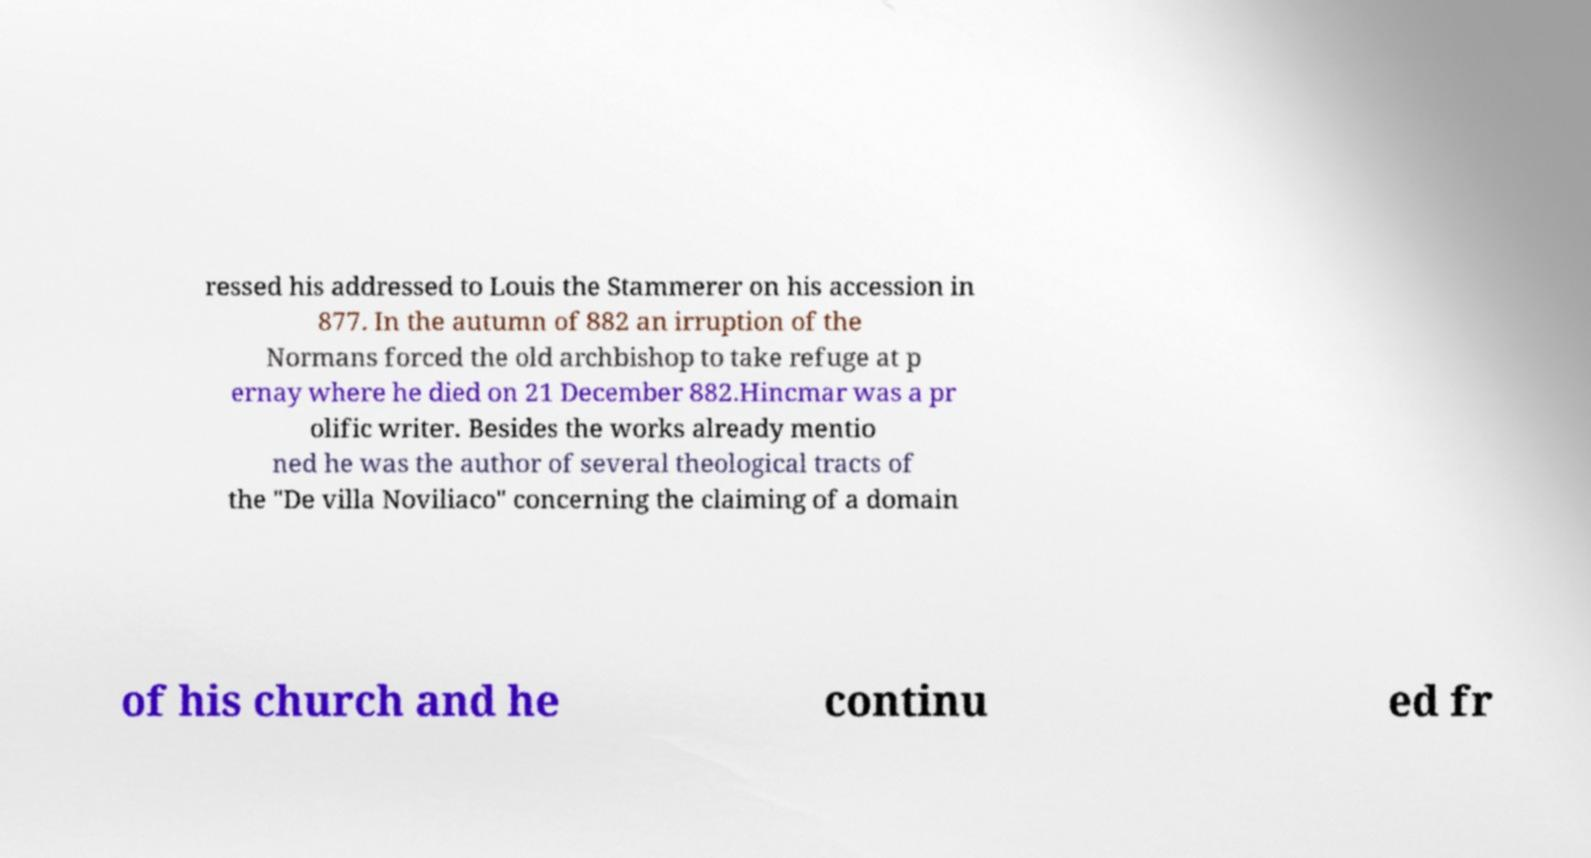Could you assist in decoding the text presented in this image and type it out clearly? ressed his addressed to Louis the Stammerer on his accession in 877. In the autumn of 882 an irruption of the Normans forced the old archbishop to take refuge at p ernay where he died on 21 December 882.Hincmar was a pr olific writer. Besides the works already mentio ned he was the author of several theological tracts of the "De villa Noviliaco" concerning the claiming of a domain of his church and he continu ed fr 